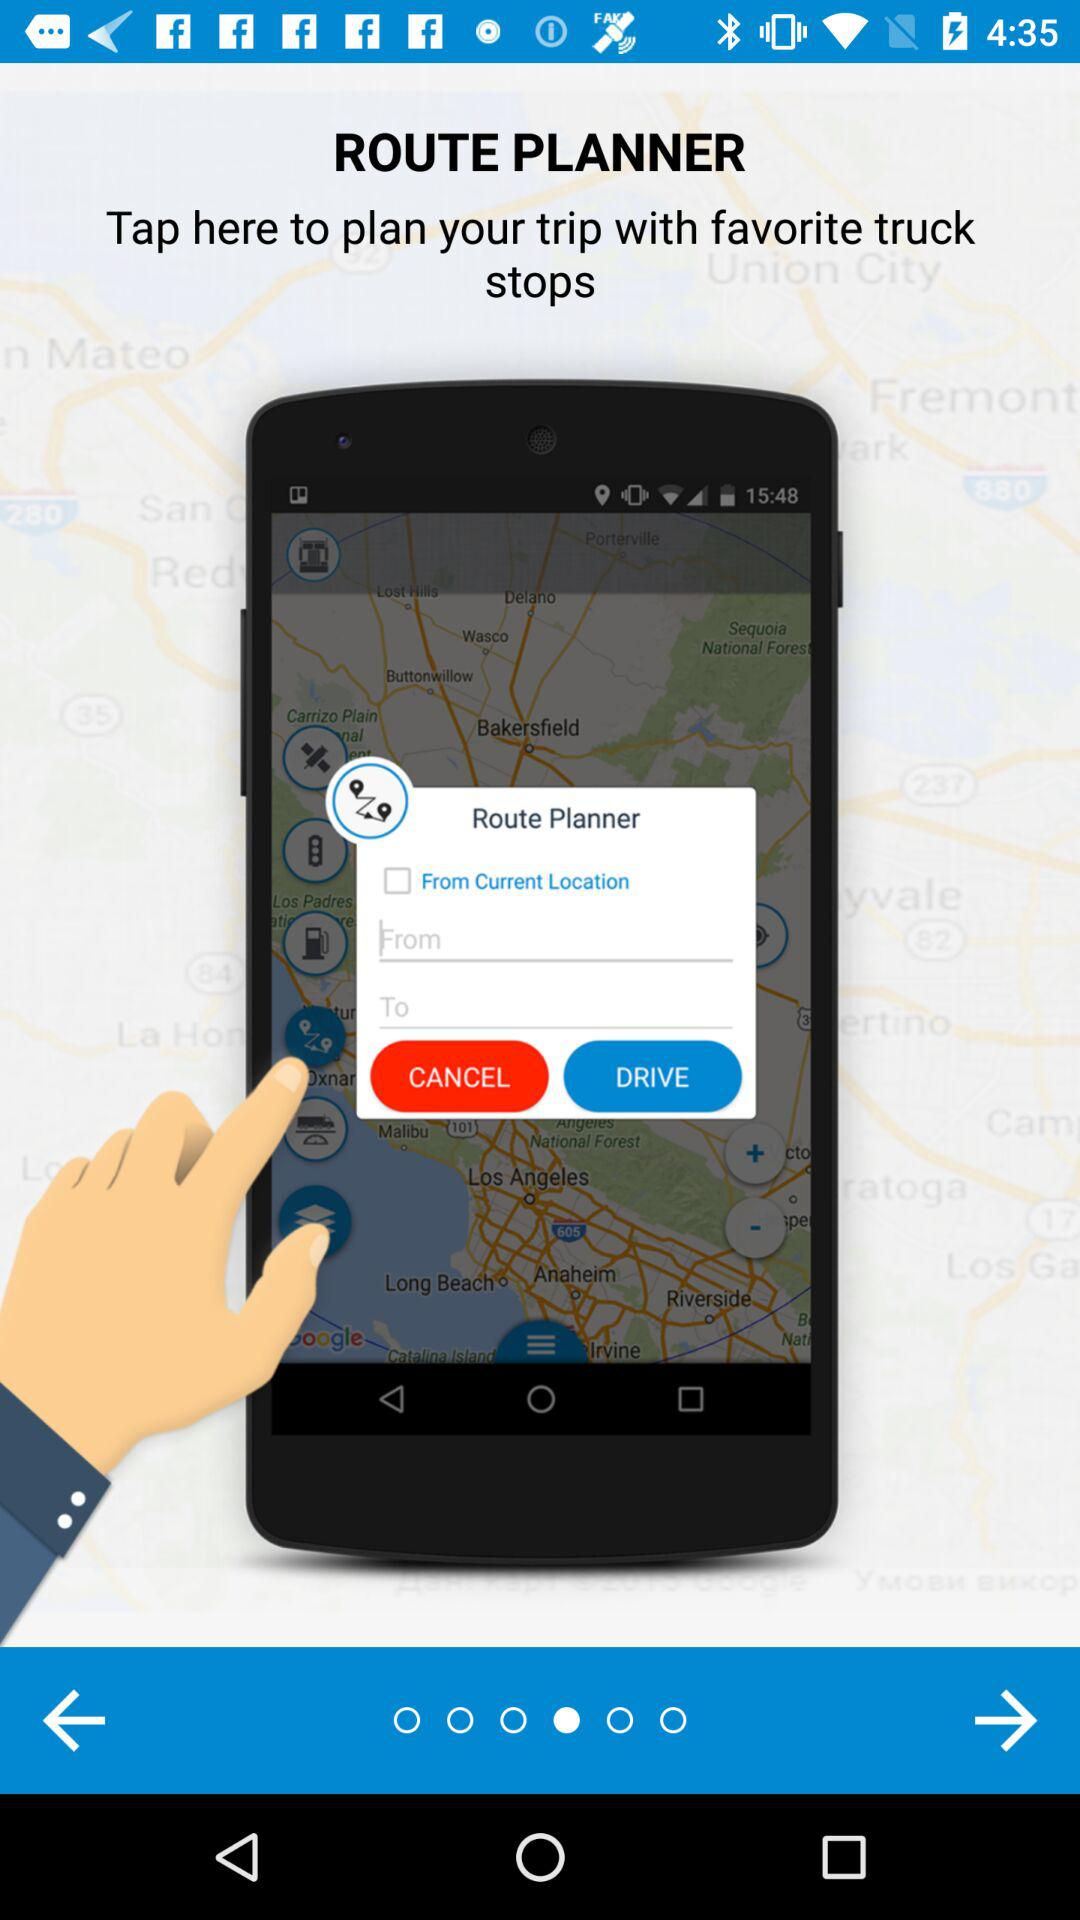What is the name of the application? The name of the application is "ROUTE PLANNER". 